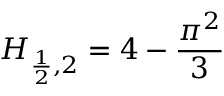<formula> <loc_0><loc_0><loc_500><loc_500>H _ { { \frac { 1 } { 2 } } , 2 } = 4 - { \frac { \pi ^ { 2 } } { 3 } }</formula> 